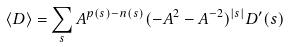<formula> <loc_0><loc_0><loc_500><loc_500>\left \langle D \right \rangle = \sum _ { s } A ^ { p ( s ) - n ( s ) } ( - A ^ { 2 } - A ^ { - 2 } ) ^ { | s | } D ^ { \prime } ( s )</formula> 